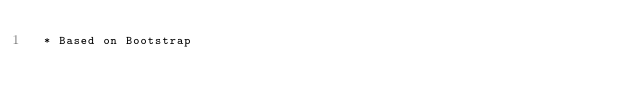<code> <loc_0><loc_0><loc_500><loc_500><_CSS_> * Based on Bootstrap</code> 